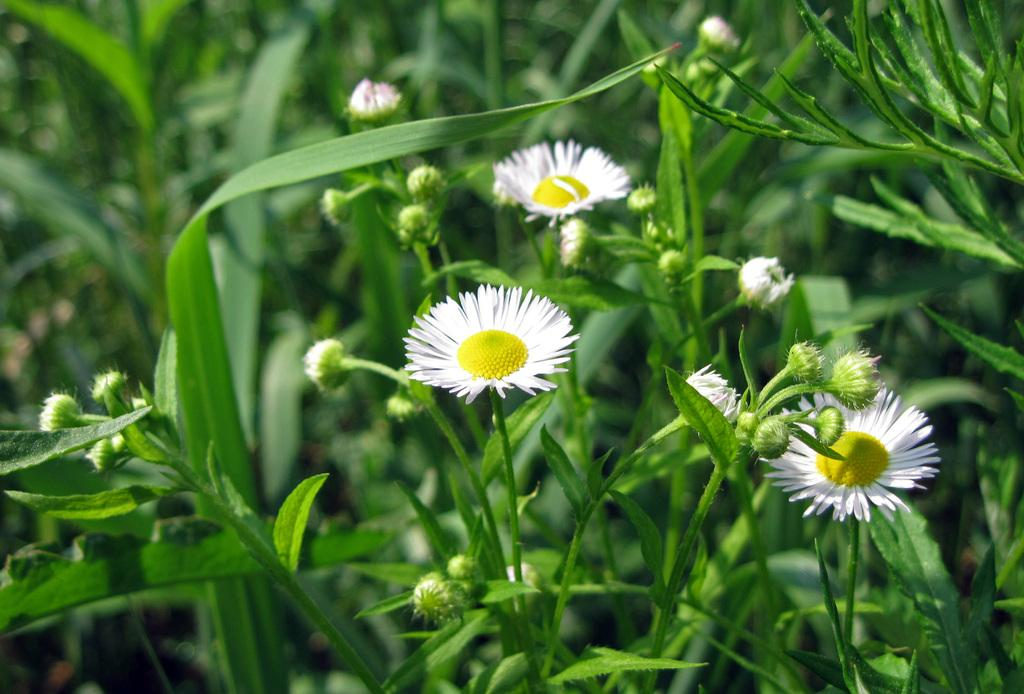What type of living organisms can be seen in the image? There are flowers in the image. Where are the flowers located? The flowers are present on plants. What type of music is the band playing in the image? There is no band present in the image, so it's not possible to determine what type of music they might be playing. 